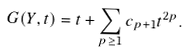<formula> <loc_0><loc_0><loc_500><loc_500>G ( Y , t ) = t + \sum _ { p \geq 1 } c _ { p + 1 } t ^ { 2 p } .</formula> 